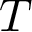<formula> <loc_0><loc_0><loc_500><loc_500>T</formula> 